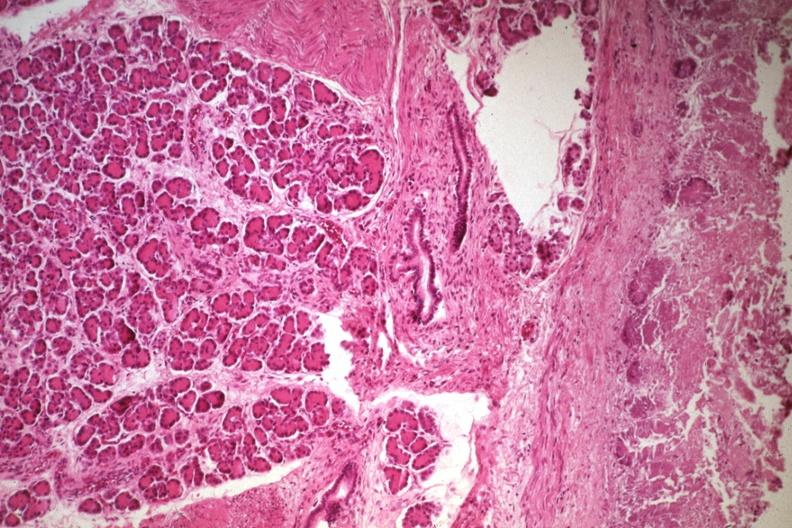what is present?
Answer the question using a single word or phrase. Ectopic pancreas 